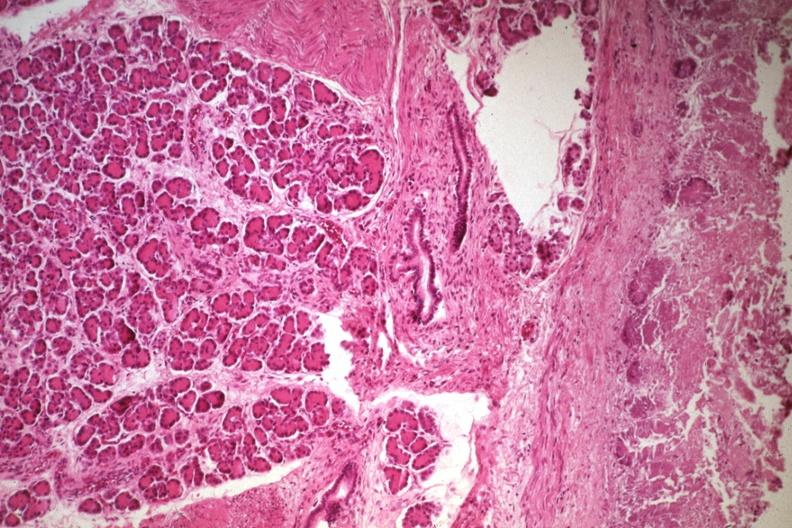what is present?
Answer the question using a single word or phrase. Ectopic pancreas 